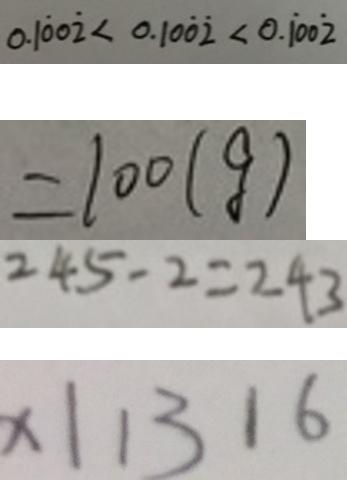Convert formula to latex. <formula><loc_0><loc_0><loc_500><loc_500>0 . 1 \dot { 0 } 0 \dot { 2 } < 0 . 1 0 \dot { 0 } \dot { 2 } < 0 . \dot { 1 } 0 0 \dot { 2 } 
 = 1 0 0 ( g ) 
 2 4 5 - 2 = 2 4 3 
 x 1 1 3 1 6</formula> 